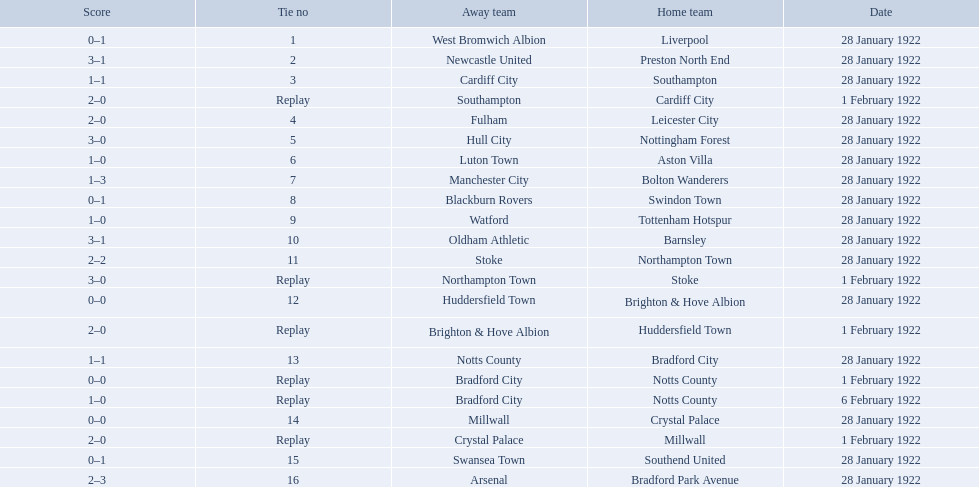Which team had a score of 0-1? Liverpool. Would you mind parsing the complete table? {'header': ['Score', 'Tie no', 'Away team', 'Home team', 'Date'], 'rows': [['0–1', '1', 'West Bromwich Albion', 'Liverpool', '28 January 1922'], ['3–1', '2', 'Newcastle United', 'Preston North End', '28 January 1922'], ['1–1', '3', 'Cardiff City', 'Southampton', '28 January 1922'], ['2–0', 'Replay', 'Southampton', 'Cardiff City', '1 February 1922'], ['2–0', '4', 'Fulham', 'Leicester City', '28 January 1922'], ['3–0', '5', 'Hull City', 'Nottingham Forest', '28 January 1922'], ['1–0', '6', 'Luton Town', 'Aston Villa', '28 January 1922'], ['1–3', '7', 'Manchester City', 'Bolton Wanderers', '28 January 1922'], ['0–1', '8', 'Blackburn Rovers', 'Swindon Town', '28 January 1922'], ['1–0', '9', 'Watford', 'Tottenham Hotspur', '28 January 1922'], ['3–1', '10', 'Oldham Athletic', 'Barnsley', '28 January 1922'], ['2–2', '11', 'Stoke', 'Northampton Town', '28 January 1922'], ['3–0', 'Replay', 'Northampton Town', 'Stoke', '1 February 1922'], ['0–0', '12', 'Huddersfield Town', 'Brighton & Hove Albion', '28 January 1922'], ['2–0', 'Replay', 'Brighton & Hove Albion', 'Huddersfield Town', '1 February 1922'], ['1–1', '13', 'Notts County', 'Bradford City', '28 January 1922'], ['0–0', 'Replay', 'Bradford City', 'Notts County', '1 February 1922'], ['1–0', 'Replay', 'Bradford City', 'Notts County', '6 February 1922'], ['0–0', '14', 'Millwall', 'Crystal Palace', '28 January 1922'], ['2–0', 'Replay', 'Crystal Palace', 'Millwall', '1 February 1922'], ['0–1', '15', 'Swansea Town', 'Southend United', '28 January 1922'], ['2–3', '16', 'Arsenal', 'Bradford Park Avenue', '28 January 1922']]} Which team had a replay? Cardiff City. Which team had the same score as aston villa? Tottenham Hotspur. 